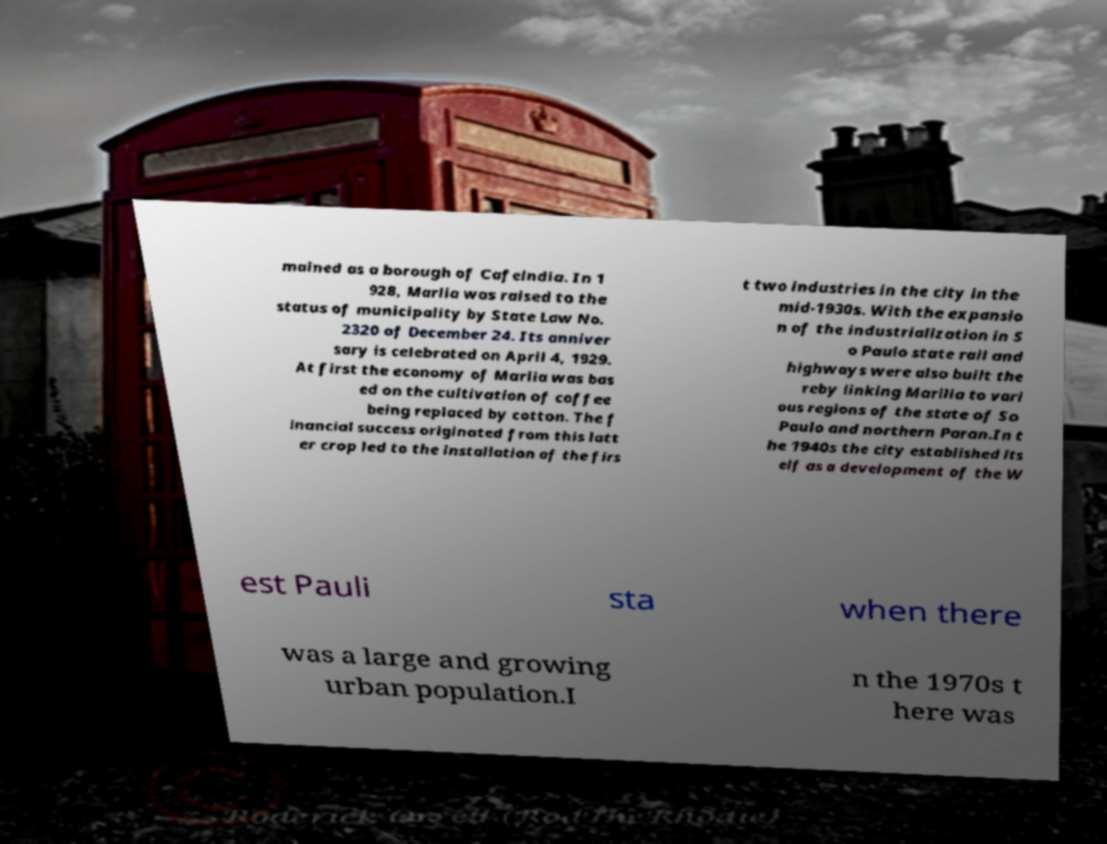Can you accurately transcribe the text from the provided image for me? mained as a borough of Cafelndia. In 1 928, Marlia was raised to the status of municipality by State Law No. 2320 of December 24. Its anniver sary is celebrated on April 4, 1929. At first the economy of Marlia was bas ed on the cultivation of coffee being replaced by cotton. The f inancial success originated from this latt er crop led to the installation of the firs t two industries in the city in the mid-1930s. With the expansio n of the industrialization in S o Paulo state rail and highways were also built the reby linking Marilia to vari ous regions of the state of So Paulo and northern Paran.In t he 1940s the city established its elf as a development of the W est Pauli sta when there was a large and growing urban population.I n the 1970s t here was 